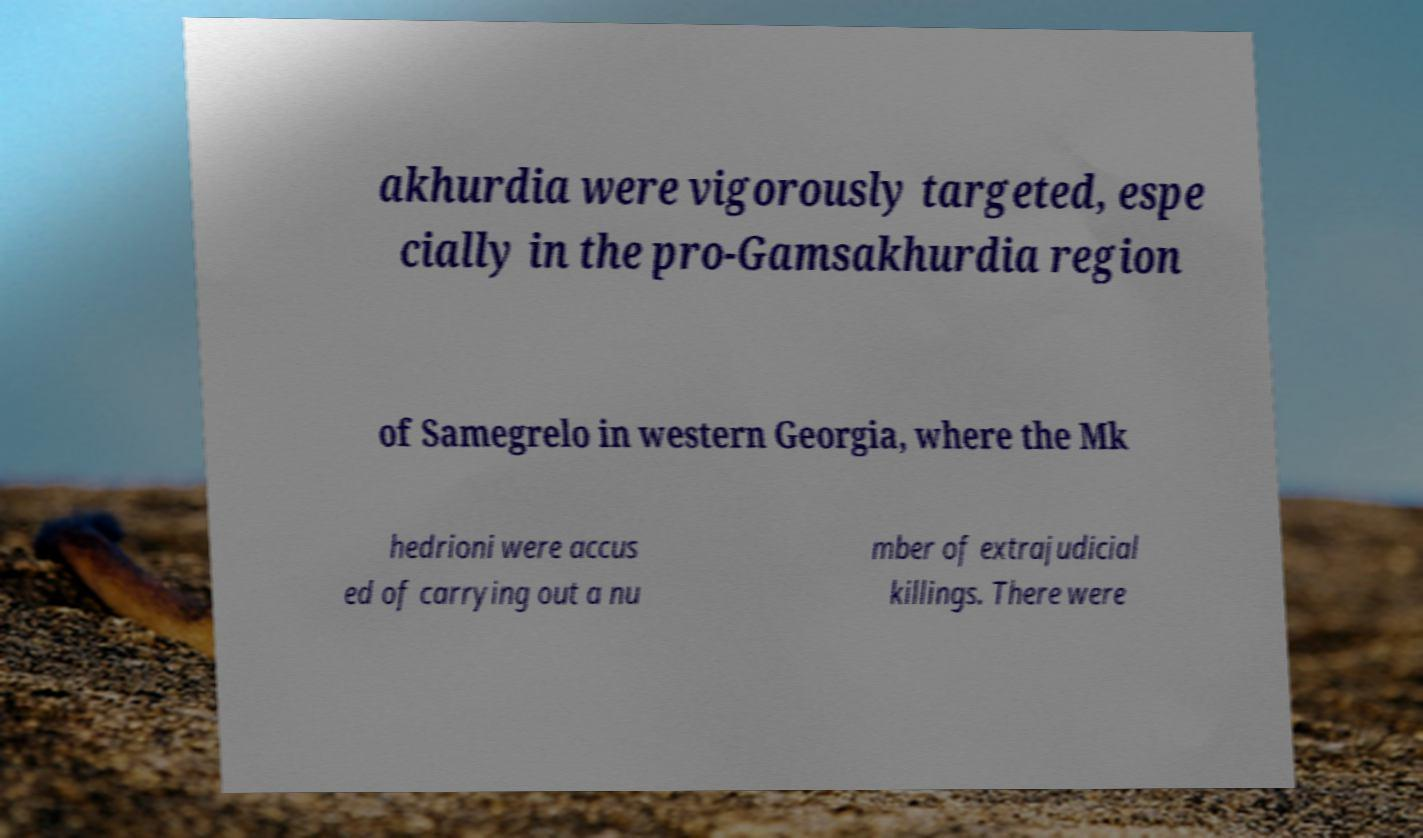For documentation purposes, I need the text within this image transcribed. Could you provide that? akhurdia were vigorously targeted, espe cially in the pro-Gamsakhurdia region of Samegrelo in western Georgia, where the Mk hedrioni were accus ed of carrying out a nu mber of extrajudicial killings. There were 